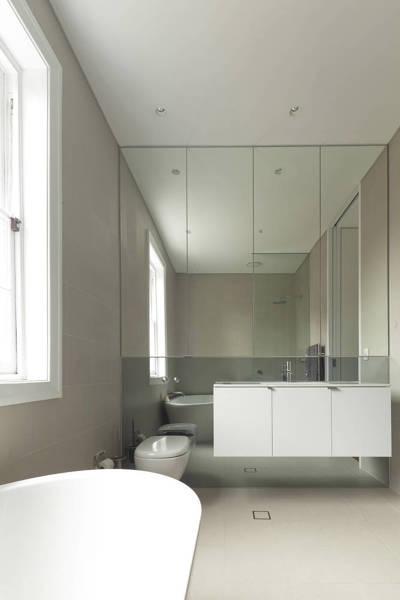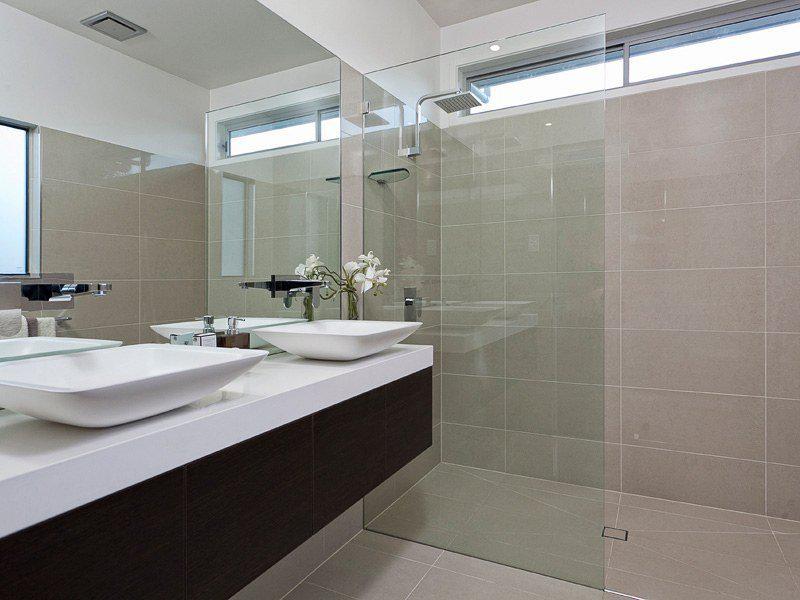The first image is the image on the left, the second image is the image on the right. Given the left and right images, does the statement "There are four faucets" hold true? Answer yes or no. No. The first image is the image on the left, the second image is the image on the right. For the images shown, is this caption "There are two separate but raised square sinks sitting on top of a wooden cabinet facing front left." true? Answer yes or no. No. 